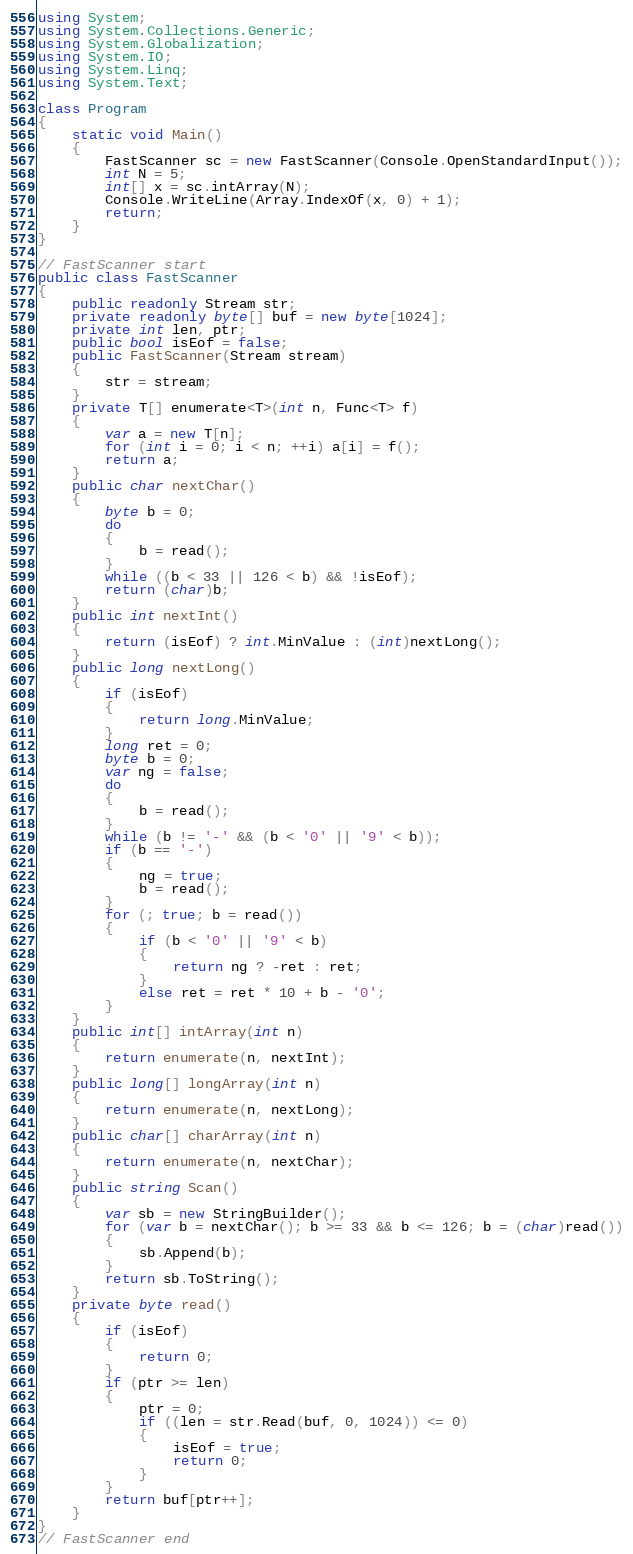Convert code to text. <code><loc_0><loc_0><loc_500><loc_500><_C#_>using System;
using System.Collections.Generic;
using System.Globalization;
using System.IO;
using System.Linq;
using System.Text;

class Program
{
    static void Main()
    {
        FastScanner sc = new FastScanner(Console.OpenStandardInput());
        int N = 5;
        int[] x = sc.intArray(N);
        Console.WriteLine(Array.IndexOf(x, 0) + 1);
        return;
    }
}

// FastScanner start
public class FastScanner
{
    public readonly Stream str;
    private readonly byte[] buf = new byte[1024];
    private int len, ptr;
    public bool isEof = false;
    public FastScanner(Stream stream)
    {
        str = stream;
    }
    private T[] enumerate<T>(int n, Func<T> f)
    {
        var a = new T[n];
        for (int i = 0; i < n; ++i) a[i] = f();
        return a;
    }
    public char nextChar()
    {
        byte b = 0;
        do
        {
            b = read();
        }
        while ((b < 33 || 126 < b) && !isEof);
        return (char)b;
    }
    public int nextInt()
    {
        return (isEof) ? int.MinValue : (int)nextLong();
    }
    public long nextLong()
    {
        if (isEof)
        {
            return long.MinValue;
        }
        long ret = 0;
        byte b = 0;
        var ng = false;
        do
        {
            b = read();
        }
        while (b != '-' && (b < '0' || '9' < b));
        if (b == '-')
        {
            ng = true;
            b = read();
        }
        for (; true; b = read())
        {
            if (b < '0' || '9' < b)
            {
                return ng ? -ret : ret;
            }
            else ret = ret * 10 + b - '0';
        }
    }
    public int[] intArray(int n)
    {
        return enumerate(n, nextInt);
    }
    public long[] longArray(int n)
    {
        return enumerate(n, nextLong);
    }
    public char[] charArray(int n)
    {
        return enumerate(n, nextChar);
    }
    public string Scan()
    {
        var sb = new StringBuilder();
        for (var b = nextChar(); b >= 33 && b <= 126; b = (char)read())
        {
            sb.Append(b);
        }
        return sb.ToString();
    }
    private byte read()
    {
        if (isEof)
        {
            return 0;
        }
        if (ptr >= len)
        {
            ptr = 0;
            if ((len = str.Read(buf, 0, 1024)) <= 0)
            {
                isEof = true;
                return 0;
            }
        }
        return buf[ptr++];
    }
}
// FastScanner end</code> 